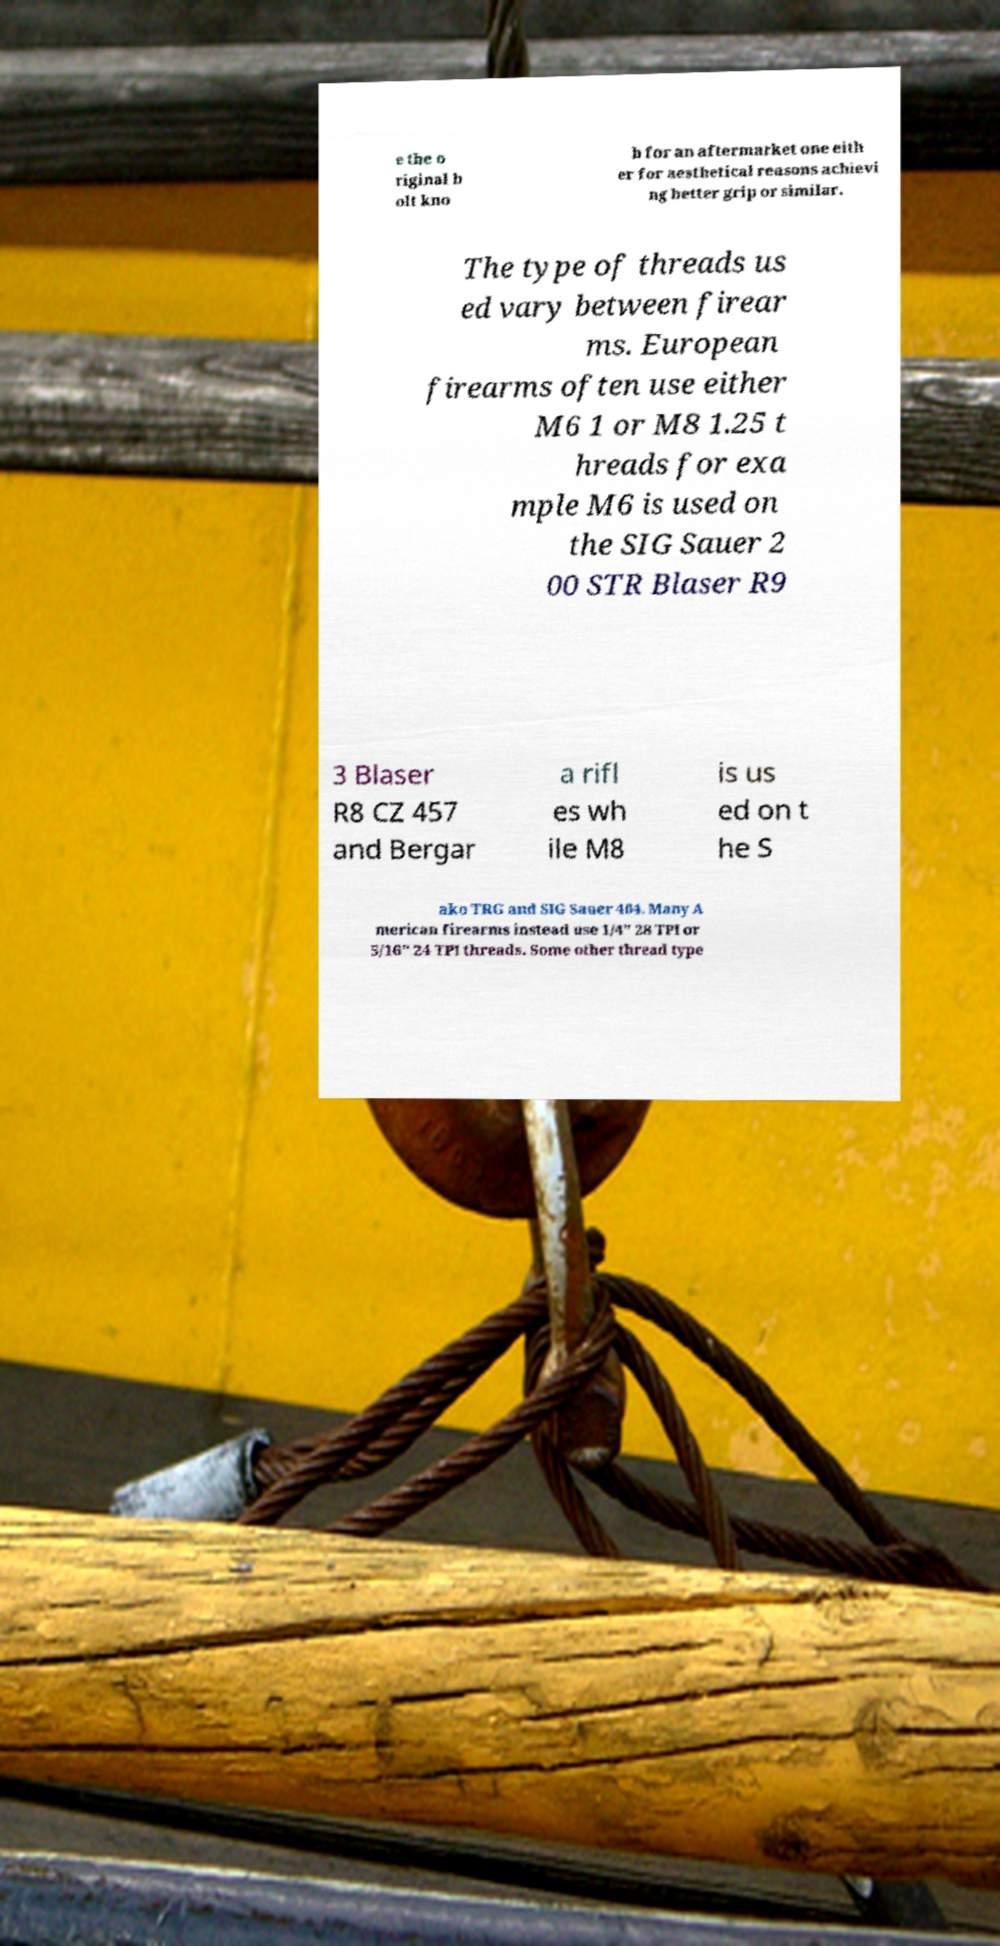Can you read and provide the text displayed in the image?This photo seems to have some interesting text. Can you extract and type it out for me? e the o riginal b olt kno b for an aftermarket one eith er for aesthetical reasons achievi ng better grip or similar. The type of threads us ed vary between firear ms. European firearms often use either M6 1 or M8 1.25 t hreads for exa mple M6 is used on the SIG Sauer 2 00 STR Blaser R9 3 Blaser R8 CZ 457 and Bergar a rifl es wh ile M8 is us ed on t he S ako TRG and SIG Sauer 404. Many A merican firearms instead use 1/4" 28 TPI or 5/16" 24 TPI threads. Some other thread type 